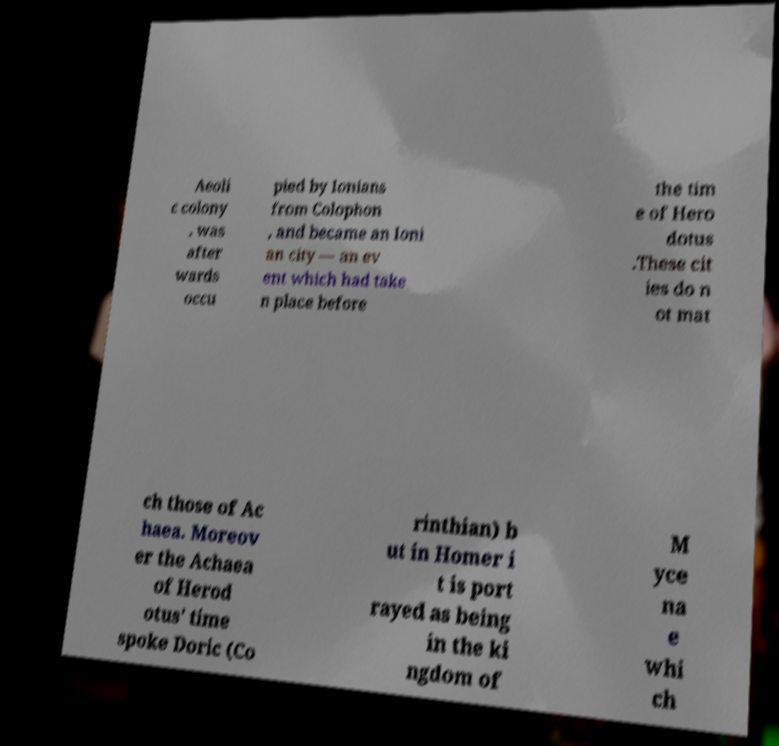Could you extract and type out the text from this image? Aeoli c colony , was after wards occu pied by Ionians from Colophon , and became an Ioni an city — an ev ent which had take n place before the tim e of Hero dotus .These cit ies do n ot mat ch those of Ac haea. Moreov er the Achaea of Herod otus' time spoke Doric (Co rinthian) b ut in Homer i t is port rayed as being in the ki ngdom of M yce na e whi ch 